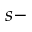<formula> <loc_0><loc_0><loc_500><loc_500>s -</formula> 